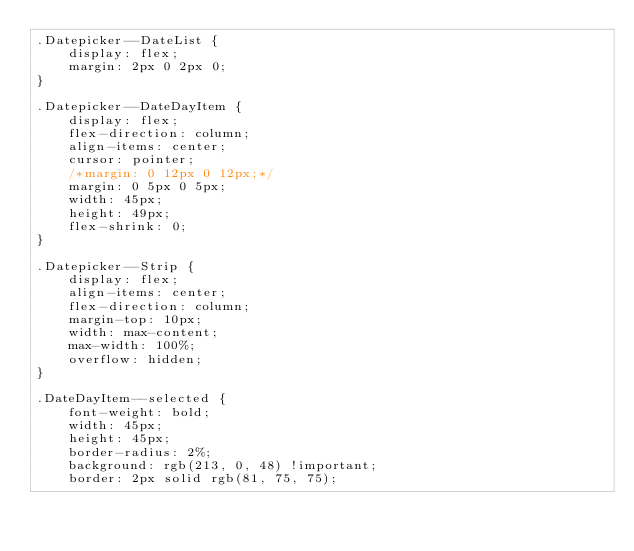Convert code to text. <code><loc_0><loc_0><loc_500><loc_500><_CSS_>.Datepicker--DateList {
    display: flex;
    margin: 2px 0 2px 0;
}

.Datepicker--DateDayItem {
    display: flex;
    flex-direction: column;
    align-items: center;
    cursor: pointer;
    /*margin: 0 12px 0 12px;*/
    margin: 0 5px 0 5px;
    width: 45px;
    height: 49px;
    flex-shrink: 0;
}

.Datepicker--Strip {
    display: flex;
    align-items: center;
    flex-direction: column;
    margin-top: 10px;
    width: max-content;
    max-width: 100%;
    overflow: hidden;
}

.DateDayItem--selected {
    font-weight: bold;
    width: 45px;
    height: 45px;
    border-radius: 2%;
    background: rgb(213, 0, 48) !important;
    border: 2px solid rgb(81, 75, 75);</code> 